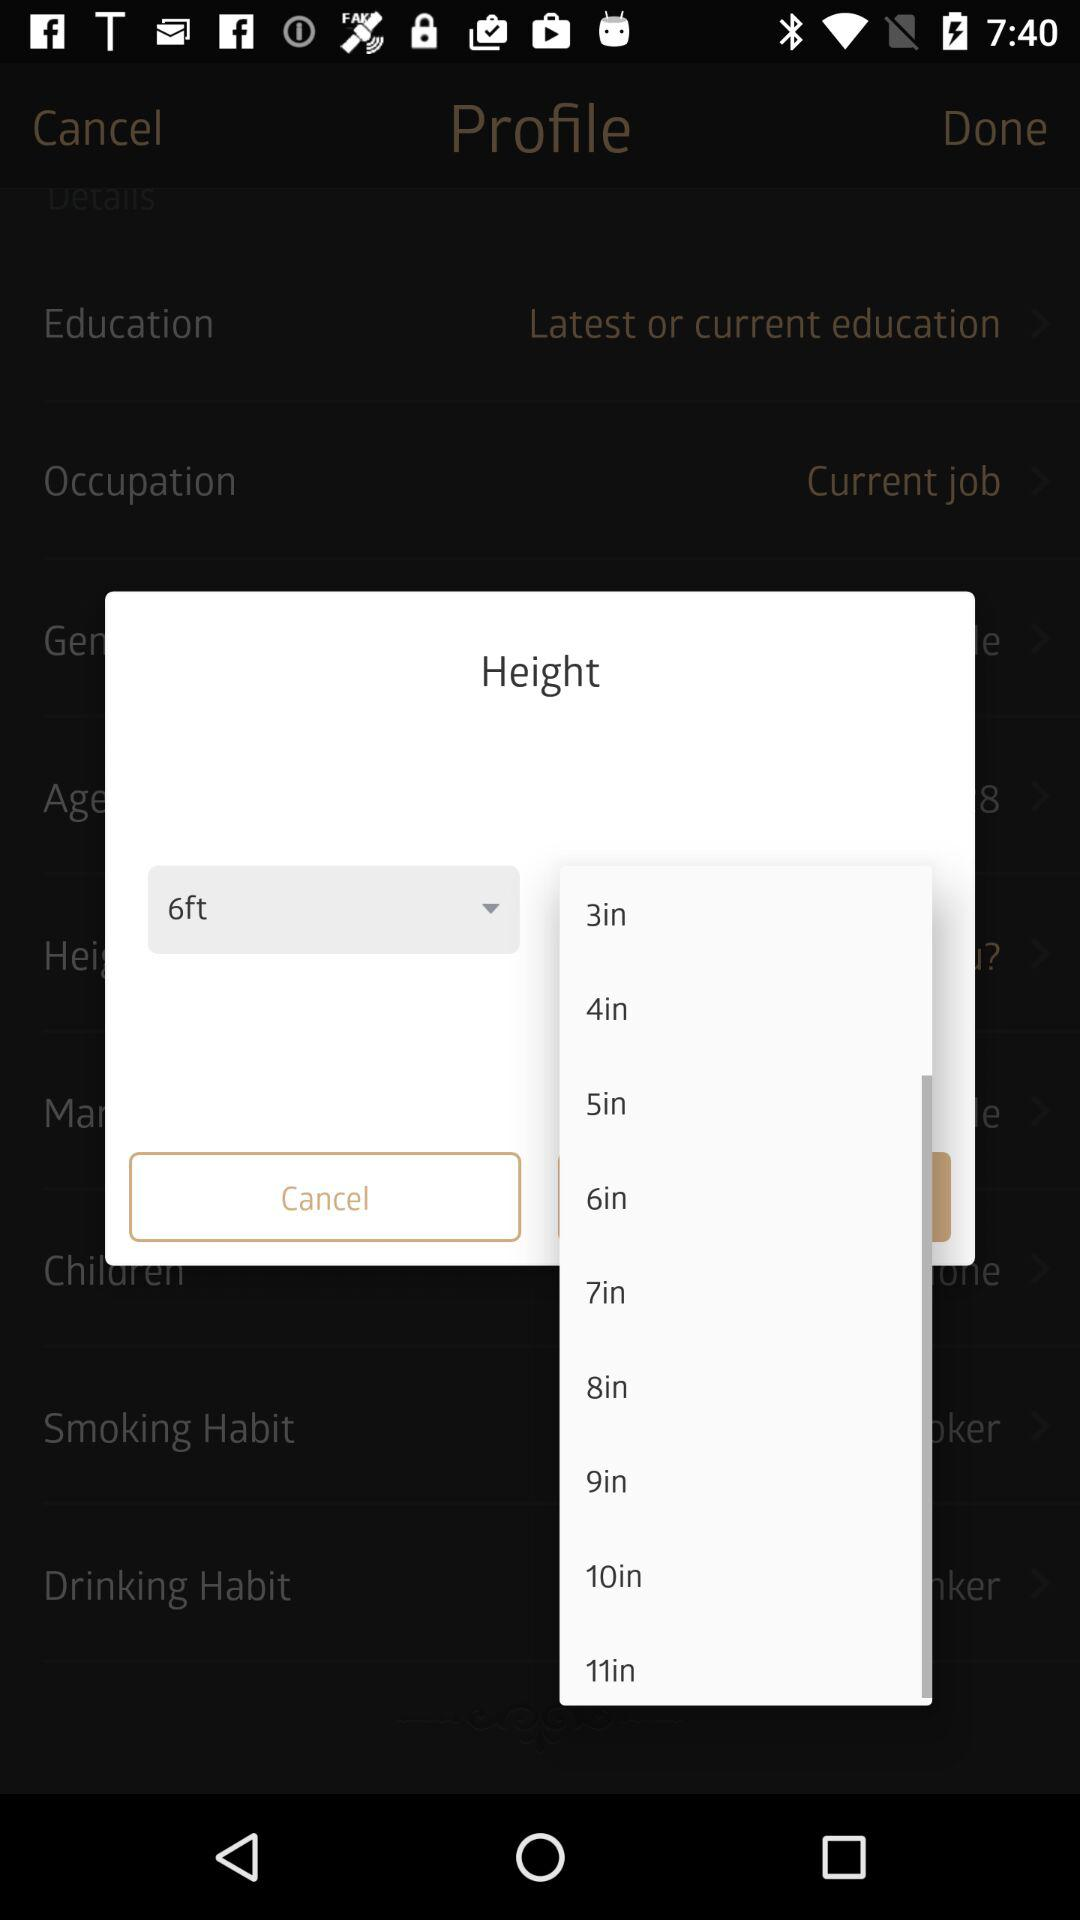How many inches are between the shortest and longest options?
Answer the question using a single word or phrase. 8 